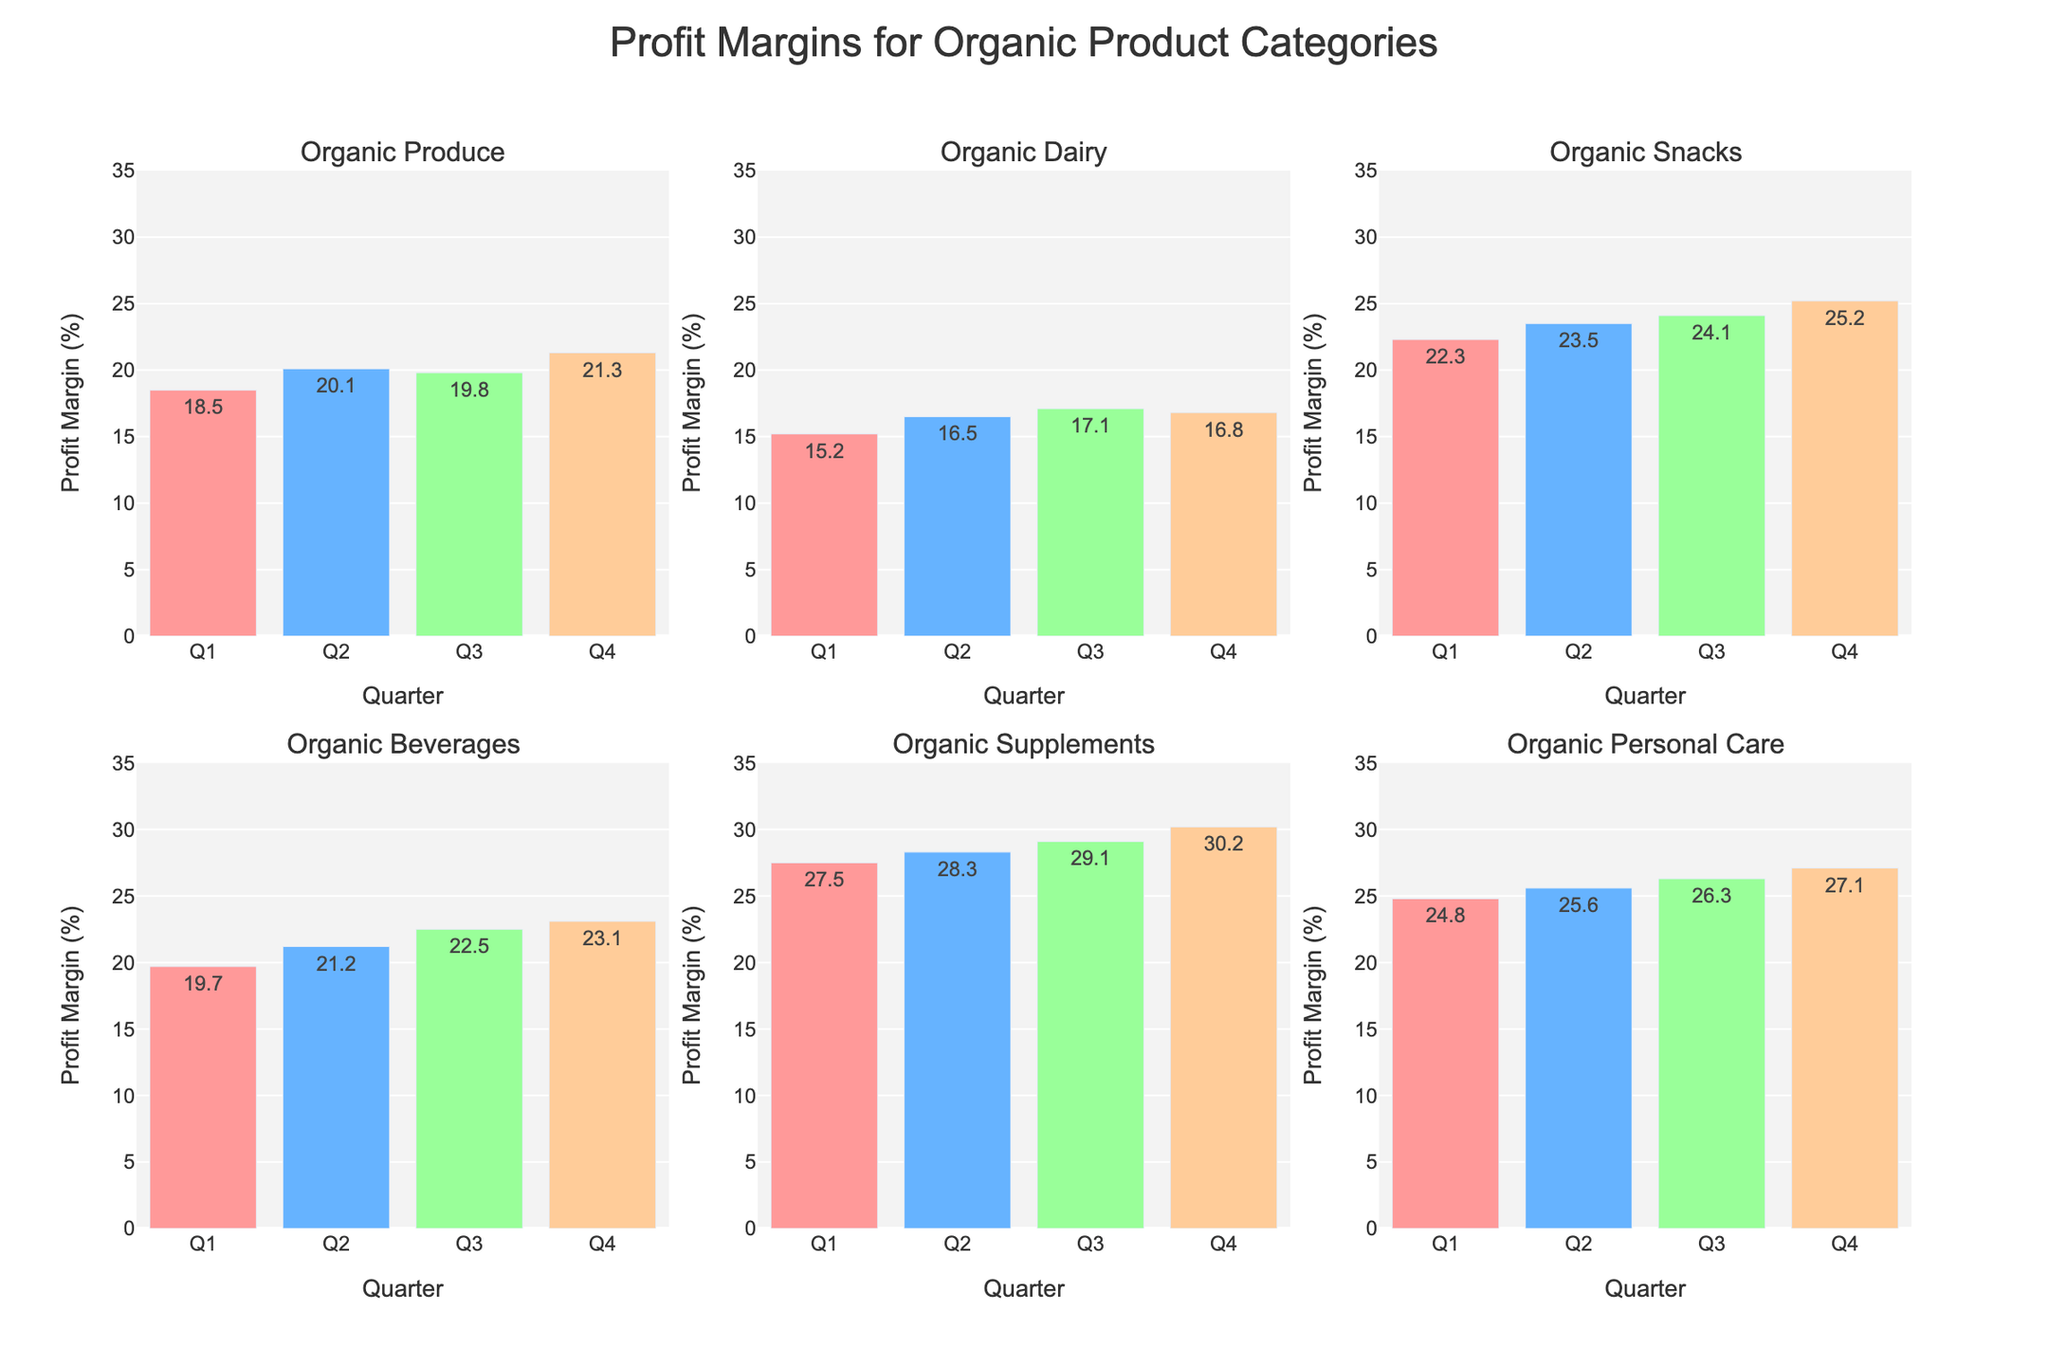What is the title of the scatterplot matrix? The title is displayed at the top of the plot in larger and bolder font. By reading it, we can understand the primary topic of the figure.
Answer: Voting Patterns Across Age Groups and Education Levels What are the different education levels represented in this figure? The education levels are indicated by distinctive colors in the scatterplot matrix. By observing the color legend, you can identify the different education levels.
Answer: High School, Bachelor's, Postgraduate How many data points represent the voting patterns for the age group 18-29 with a Bachelor's degree? To determine this, identify the markers with the label "18-29" in the hover data and "Bachelor's" in their color code. Each point shows one voting pattern. Analyzing all such points will give the count.
Answer: 4 Which candidate received the higher vote share among the 45-64 age group with Postgraduate education in the 2020 election? Hover on the points representing the 45-64 age group with Postgraduate education and filter for the 2020 election. Compare the vote share between Trump and Biden.
Answer: Biden Compare the vote shares for Trump and Clinton in the 2016 election among the 30-44 age group with a High School education. Who had more support? Identify the points for the 30-44 age group with High School education and check the vote shares for Trump and Clinton in 2016. Determine who had a higher percentage.
Answer: Trump What is the range of vote shares for Trump among all age groups and education levels in the 2020 election? Locate all points representing Trump's vote shares in 2020 across different ages and education levels. Extract the minimum and maximum values from these data points to establish the range.
Answer: 30% to 58% What is the average vote share for Biden in the 2020 election across all education levels for the 65+ age group? Hover over the points for the 65+ age group in 2020, filtering specifically for Biden. Sum the vote shares of all education levels and divide by the number of education levels (3). Detailed steps: (41 + 44 + 48) ÷ 3.
Answer: 44.3% How do the vote shares of Trump in the 45-64 age group with High School education compare between the 2016 and 2020 elections? Identify the data points for the 45-64 age group with High School education. Compare Trump's vote shares between 2016 and 2020.
Answer: Trump's vote share increased from 52% to 58% What pattern can be observed regarding the vote shares of Clinton in 2016 across different education levels for the 18-29 age group? Check the vote shares for Clinton in the 18-29 age group across High School, Bachelor's, and Postgraduate education levels. Identify any trends or consistency.
Answer: Clinton's vote share remains relatively consistent, around 55%-58%, across all education levels 